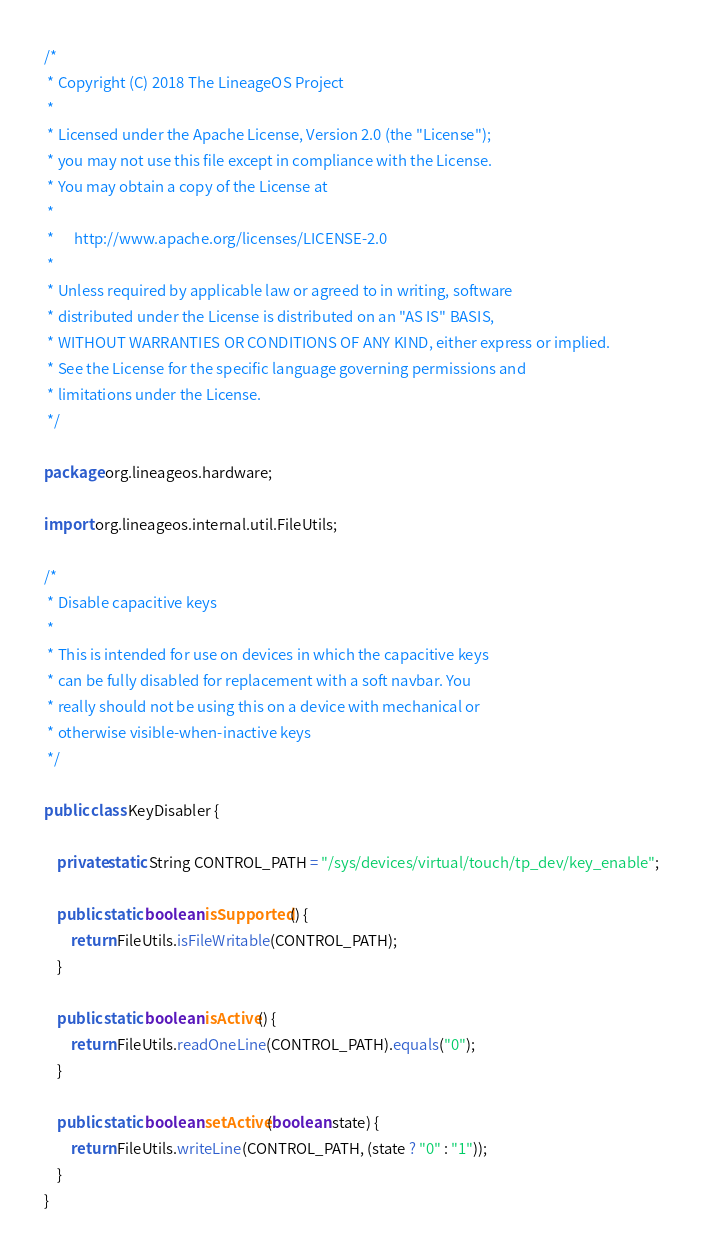<code> <loc_0><loc_0><loc_500><loc_500><_Java_>/*
 * Copyright (C) 2018 The LineageOS Project
 *
 * Licensed under the Apache License, Version 2.0 (the "License");
 * you may not use this file except in compliance with the License.
 * You may obtain a copy of the License at
 *
 *      http://www.apache.org/licenses/LICENSE-2.0
 *
 * Unless required by applicable law or agreed to in writing, software
 * distributed under the License is distributed on an "AS IS" BASIS,
 * WITHOUT WARRANTIES OR CONDITIONS OF ANY KIND, either express or implied.
 * See the License for the specific language governing permissions and
 * limitations under the License.
 */

package org.lineageos.hardware;

import org.lineageos.internal.util.FileUtils;

/*
 * Disable capacitive keys
 *
 * This is intended for use on devices in which the capacitive keys
 * can be fully disabled for replacement with a soft navbar. You
 * really should not be using this on a device with mechanical or
 * otherwise visible-when-inactive keys
 */

public class KeyDisabler {

    private static String CONTROL_PATH = "/sys/devices/virtual/touch/tp_dev/key_enable";

    public static boolean isSupported() {
        return FileUtils.isFileWritable(CONTROL_PATH);
    }

    public static boolean isActive() {
        return FileUtils.readOneLine(CONTROL_PATH).equals("0");
    }

    public static boolean setActive(boolean state) {
        return FileUtils.writeLine(CONTROL_PATH, (state ? "0" : "1"));
    }
}
</code> 